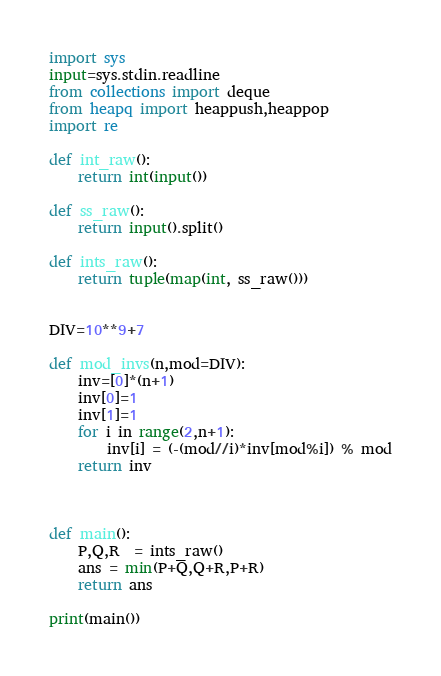<code> <loc_0><loc_0><loc_500><loc_500><_Python_>import sys
input=sys.stdin.readline
from collections import deque
from heapq import heappush,heappop
import re

def int_raw():
    return int(input())
 
def ss_raw():
    return input().split()
 
def ints_raw():
    return tuple(map(int, ss_raw()))


DIV=10**9+7

def mod_invs(n,mod=DIV):
    inv=[0]*(n+1)
    inv[0]=1
    inv[1]=1
    for i in range(2,n+1):
        inv[i] = (-(mod//i)*inv[mod%i]) % mod
    return inv



def main():
    P,Q,R  = ints_raw()
    ans = min(P+Q,Q+R,P+R)
    return ans

print(main())
</code> 